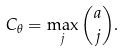<formula> <loc_0><loc_0><loc_500><loc_500>C _ { \theta } = \max _ { j } { a \choose j } .</formula> 